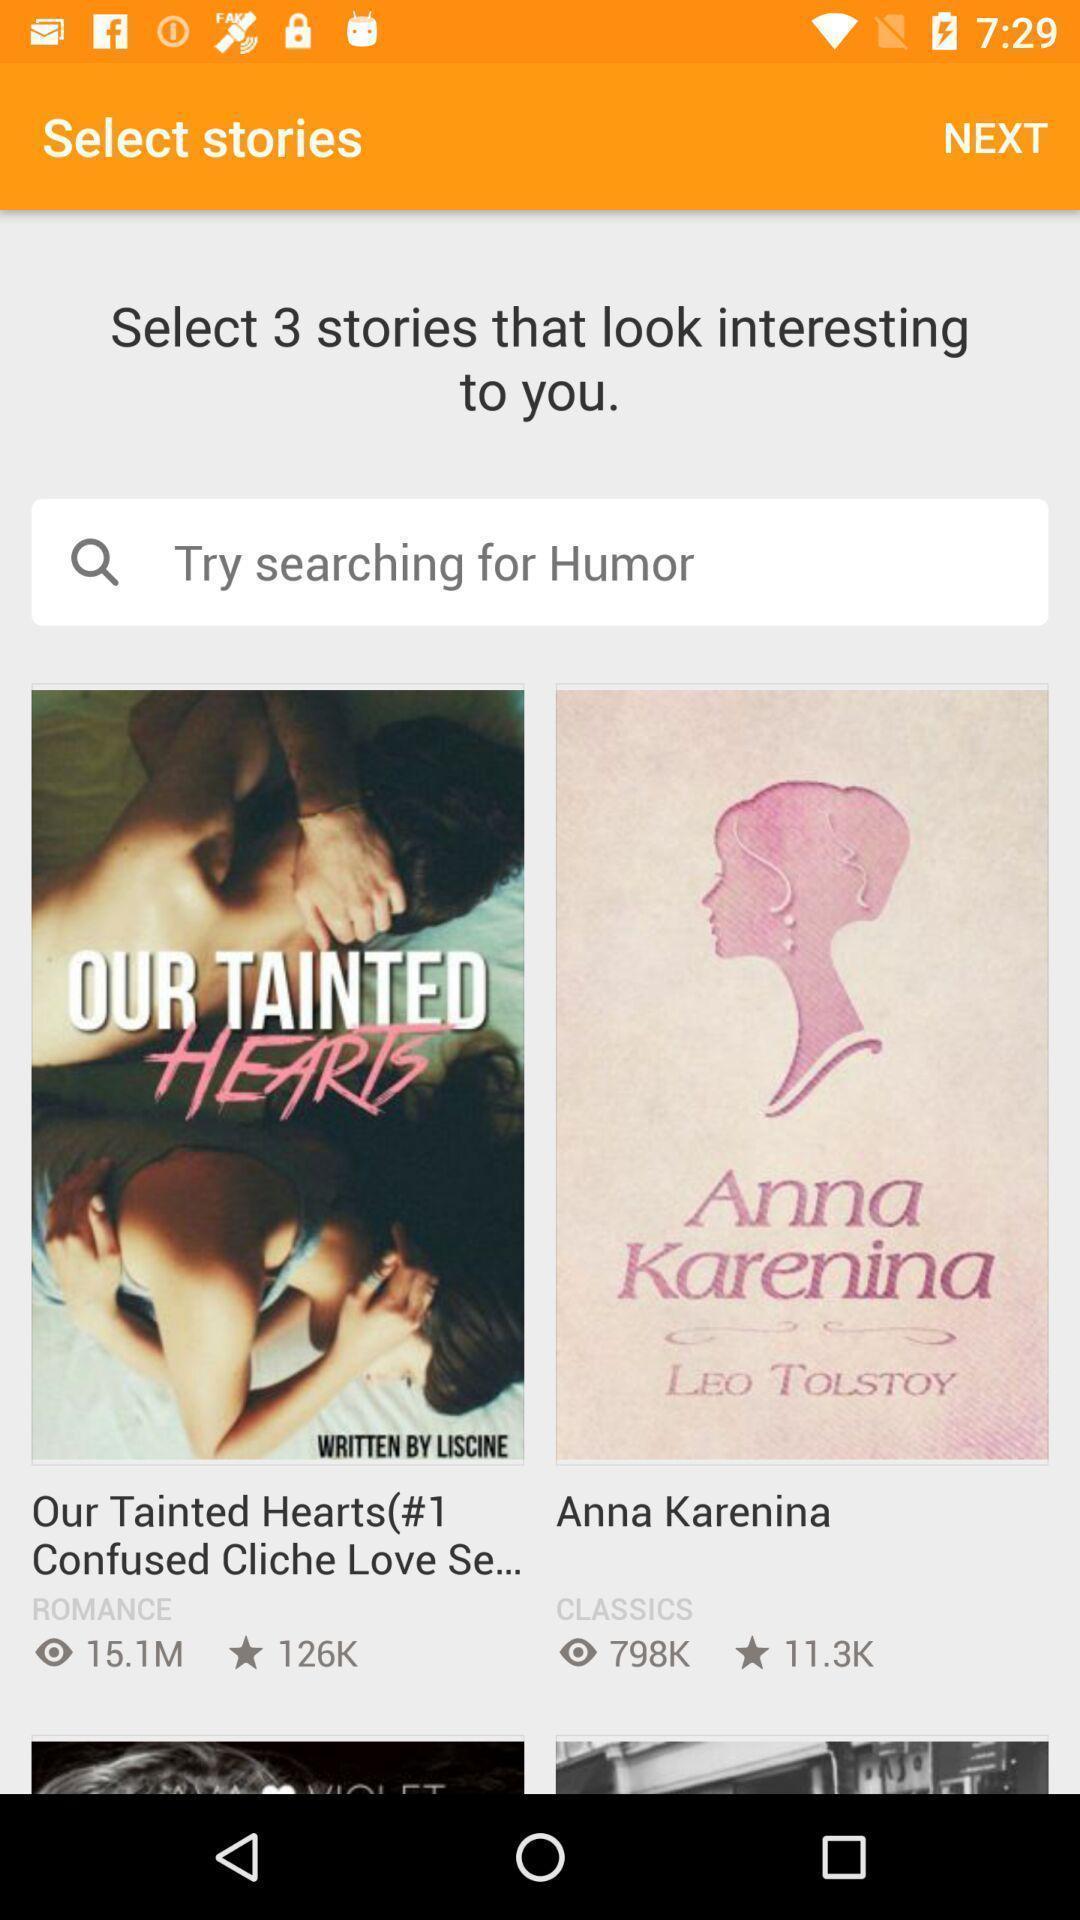Describe the key features of this screenshot. Search bar to select the stories. 